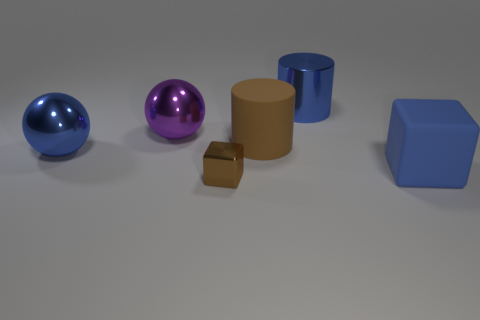What number of objects are metal objects on the left side of the metal cube or blue objects?
Give a very brief answer. 4. Does the brown matte object have the same size as the metallic thing that is behind the large purple metal ball?
Ensure brevity in your answer.  Yes. How many large objects are either brown cylinders or matte cubes?
Make the answer very short. 2. The large purple metallic object has what shape?
Make the answer very short. Sphere. There is a metal cylinder that is the same color as the large cube; what size is it?
Ensure brevity in your answer.  Large. Are there any purple things made of the same material as the large block?
Offer a very short reply. No. Is the number of purple metallic things greater than the number of tiny yellow shiny spheres?
Keep it short and to the point. Yes. Is the material of the large block the same as the large brown cylinder?
Offer a very short reply. Yes. How many metal objects are either tiny yellow cylinders or blue cylinders?
Your answer should be compact. 1. There is a metallic cylinder that is the same size as the blue rubber cube; what is its color?
Ensure brevity in your answer.  Blue. 